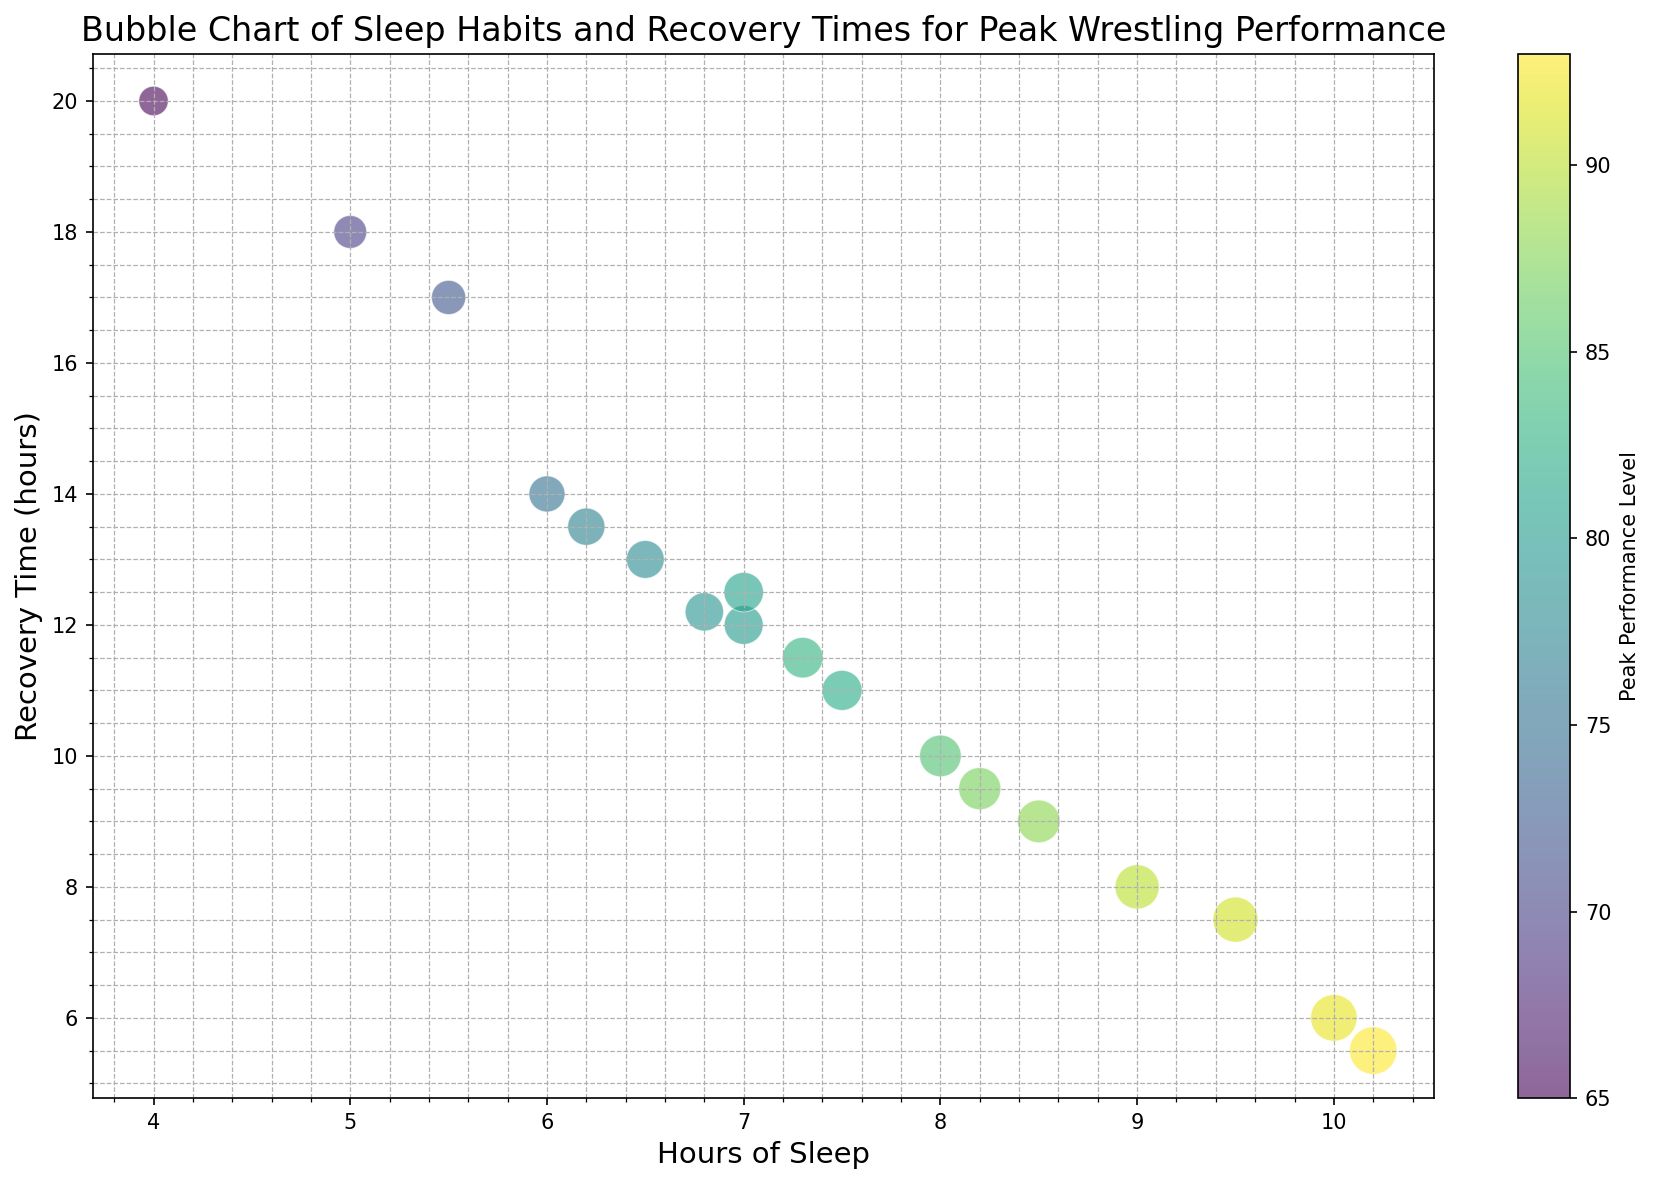How many data points have recovery times less than 10 hours and peak performance levels above 85? First, filter the data points with recovery times less than 10 hours: {8, 9, and 9.5}. Then, among these, check for those with peak performance levels above 85: {85, 88, and 87}. Count these points.
Answer: 3 Which data point has the highest bubble size, and what are its hours of sleep and peak performance level? Identify the data point with the highest bubble size, which is 52. This corresponds to Hours_of_Sleep=10.2 and Peak_Performance_Level=93.
Answer: 10.2 hours, 93 Which data point has the highest recovery time, and what is its peak performance level? Identify the data point with the highest recovery time, which is 20 hours. This corresponds to a Peak_Performance_Level of 65.
Answer: 65 What is the average number of hours of sleep for data points with a peak performance level of 90 or above? Select data points with Peak_Performance_Level >= 90: {9, 10, 9.5, and 10.2 hours}. Calculate the average: (9 + 10 + 9.5 + 10.2) / 4 = 38.7 / 4.
Answer: 9.675 hours Which data point has the darkest color, and what is its recovery time? Identify the data point with the highest Peak_Performance_Level (i.e., the darkest color in the viridis colormap), which is 93. This corresponds to a Recovery_Time of 5.5 hours.
Answer: 5.5 hours What is the difference in peak performance levels between the data point with the least sleep and the most sleep? Identify the data points with the least sleep (4 hours) and the most sleep (10.2 hours). Their respective Peak_Performance_Levels are 65 and 93. The difference is 93 - 65.
Answer: 28 How many data points have a recovery time between 10 and 15 hours and what are their average Peak Performance Levels? Filter data points within the recovery time of 10 - 15 hours: {14, 12, 12.5, 11, 13, 12.2, 11.5, 13.5}. Their Peak_Performance_Levels are {75, 80, 81, 82, 78, 79, 83, 77}. Calculate the average: (75+80+81+82+78+79+83+77)/8.
Answer: 79.375 Is there any data point with 7 hours of sleep and a peak performance level of exactly 80? Check the data points with 7 hours of sleep. Among these, identify if any has a Peak_Performance_Level of 80.
Answer: Yes Which data point has the smallest bubble size and what are its hours of sleep and peak performance level? Identify the data point with the smallest bubble size, which is 20. This corresponds to Hours_of_Sleep=4 and Peak_Performance_Level=65.
Answer: 4 hours, 65 